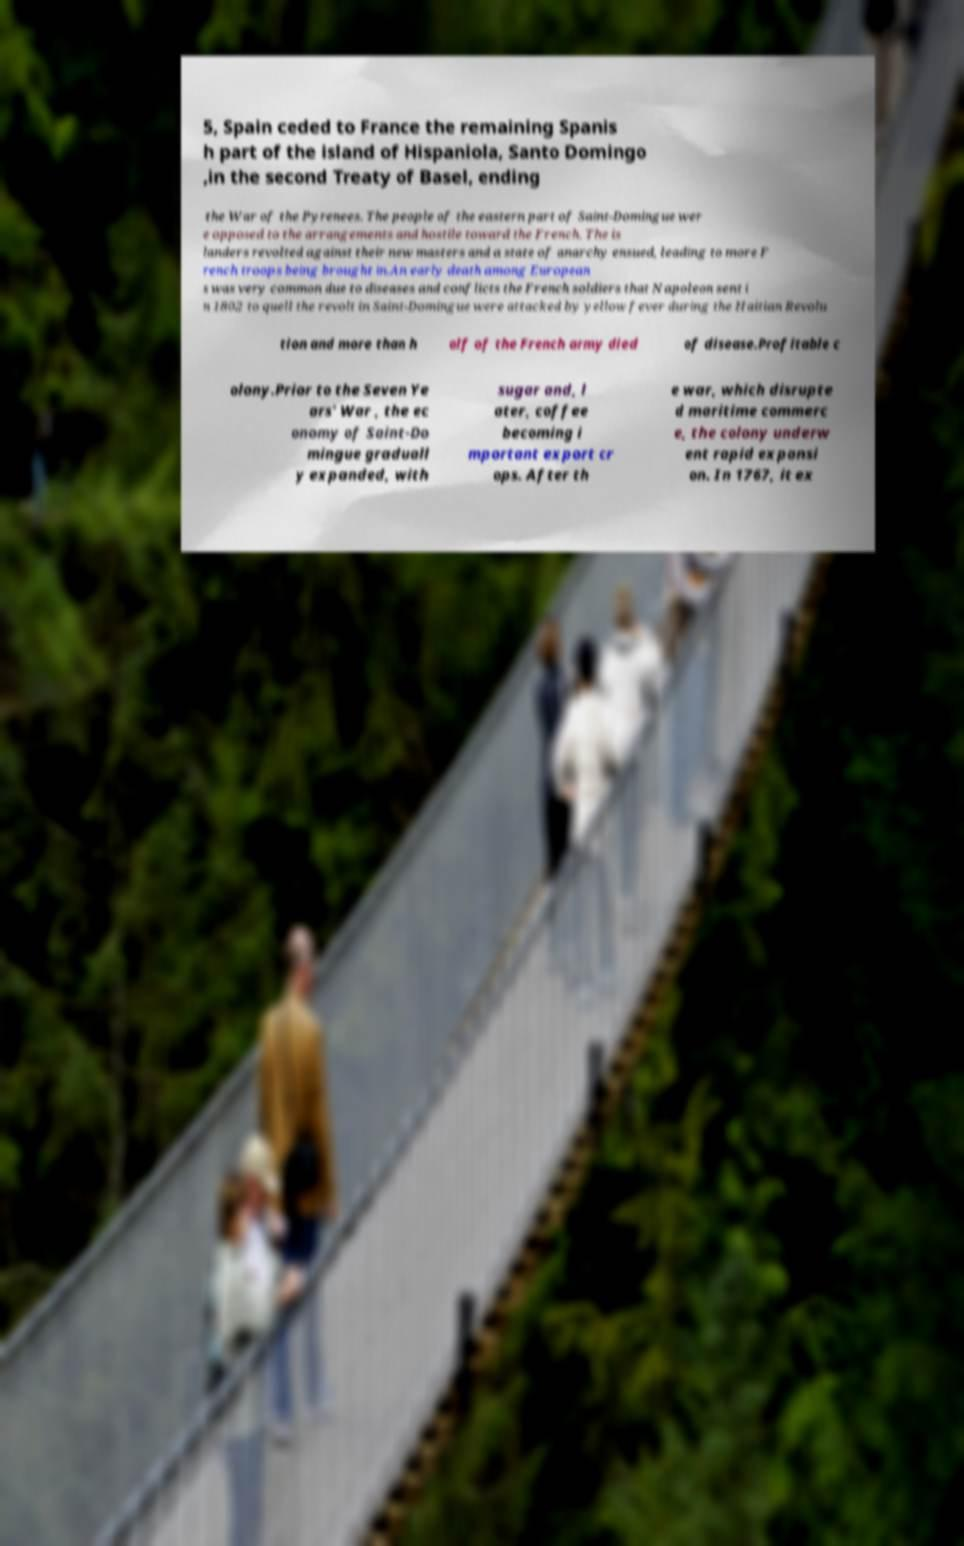Can you read and provide the text displayed in the image?This photo seems to have some interesting text. Can you extract and type it out for me? 5, Spain ceded to France the remaining Spanis h part of the island of Hispaniola, Santo Domingo ,in the second Treaty of Basel, ending the War of the Pyrenees. The people of the eastern part of Saint-Domingue wer e opposed to the arrangements and hostile toward the French. The is landers revolted against their new masters and a state of anarchy ensued, leading to more F rench troops being brought in.An early death among European s was very common due to diseases and conflicts the French soldiers that Napoleon sent i n 1802 to quell the revolt in Saint-Domingue were attacked by yellow fever during the Haitian Revolu tion and more than h alf of the French army died of disease.Profitable c olony.Prior to the Seven Ye ars' War , the ec onomy of Saint-Do mingue graduall y expanded, with sugar and, l ater, coffee becoming i mportant export cr ops. After th e war, which disrupte d maritime commerc e, the colony underw ent rapid expansi on. In 1767, it ex 